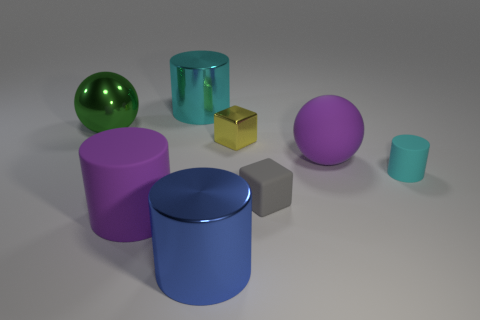What number of other objects are there of the same size as the purple matte cylinder?
Provide a short and direct response. 4. What is the material of the thing behind the large green metal ball?
Your answer should be compact. Metal. The large matte thing behind the gray object in front of the metal cylinder behind the tiny cyan matte cylinder is what shape?
Your answer should be very brief. Sphere. Do the green metal sphere and the cyan metallic cylinder have the same size?
Your answer should be compact. Yes. What number of objects are either big matte things or balls to the left of the small gray rubber thing?
Make the answer very short. 3. What number of things are either spheres behind the yellow metal block or metal cylinders in front of the yellow thing?
Your answer should be compact. 2. Are there any gray cubes to the right of the cyan shiny thing?
Offer a very short reply. Yes. What color is the large thing that is on the left side of the big purple matte object that is left of the big thing to the right of the yellow metal block?
Your answer should be compact. Green. Do the small metal object and the gray matte object have the same shape?
Offer a terse response. Yes. The other big cylinder that is the same material as the large cyan cylinder is what color?
Your answer should be very brief. Blue. 